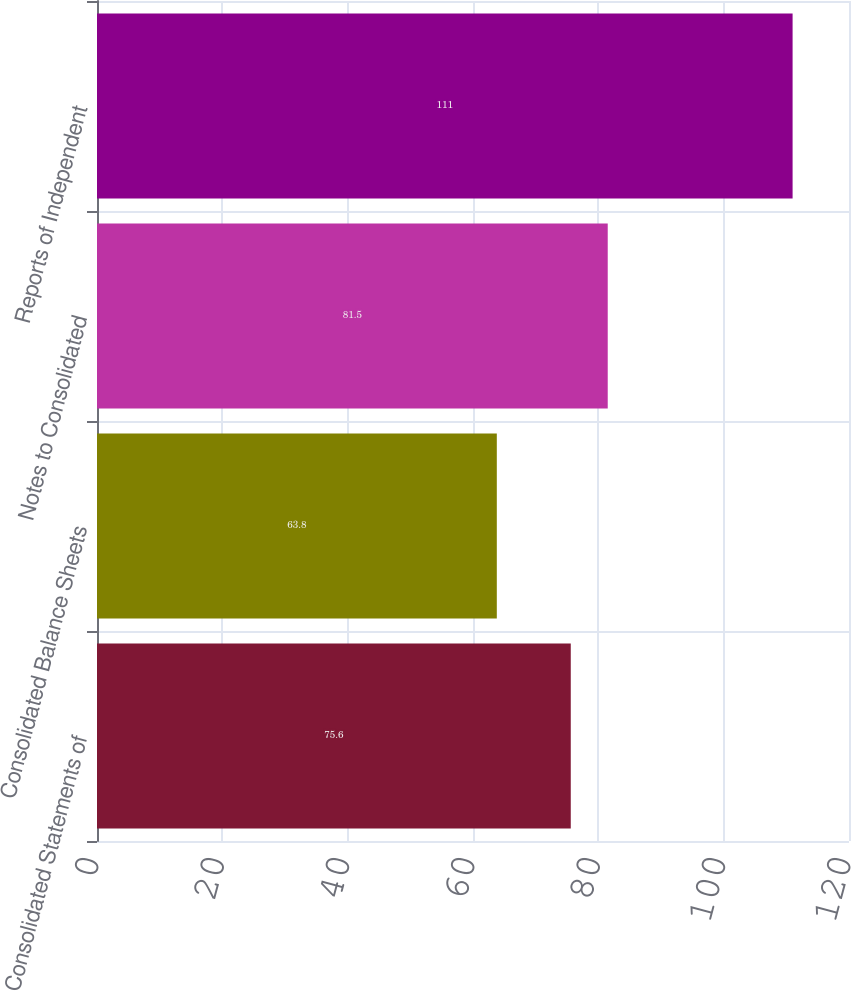<chart> <loc_0><loc_0><loc_500><loc_500><bar_chart><fcel>Consolidated Statements of<fcel>Consolidated Balance Sheets<fcel>Notes to Consolidated<fcel>Reports of Independent<nl><fcel>75.6<fcel>63.8<fcel>81.5<fcel>111<nl></chart> 